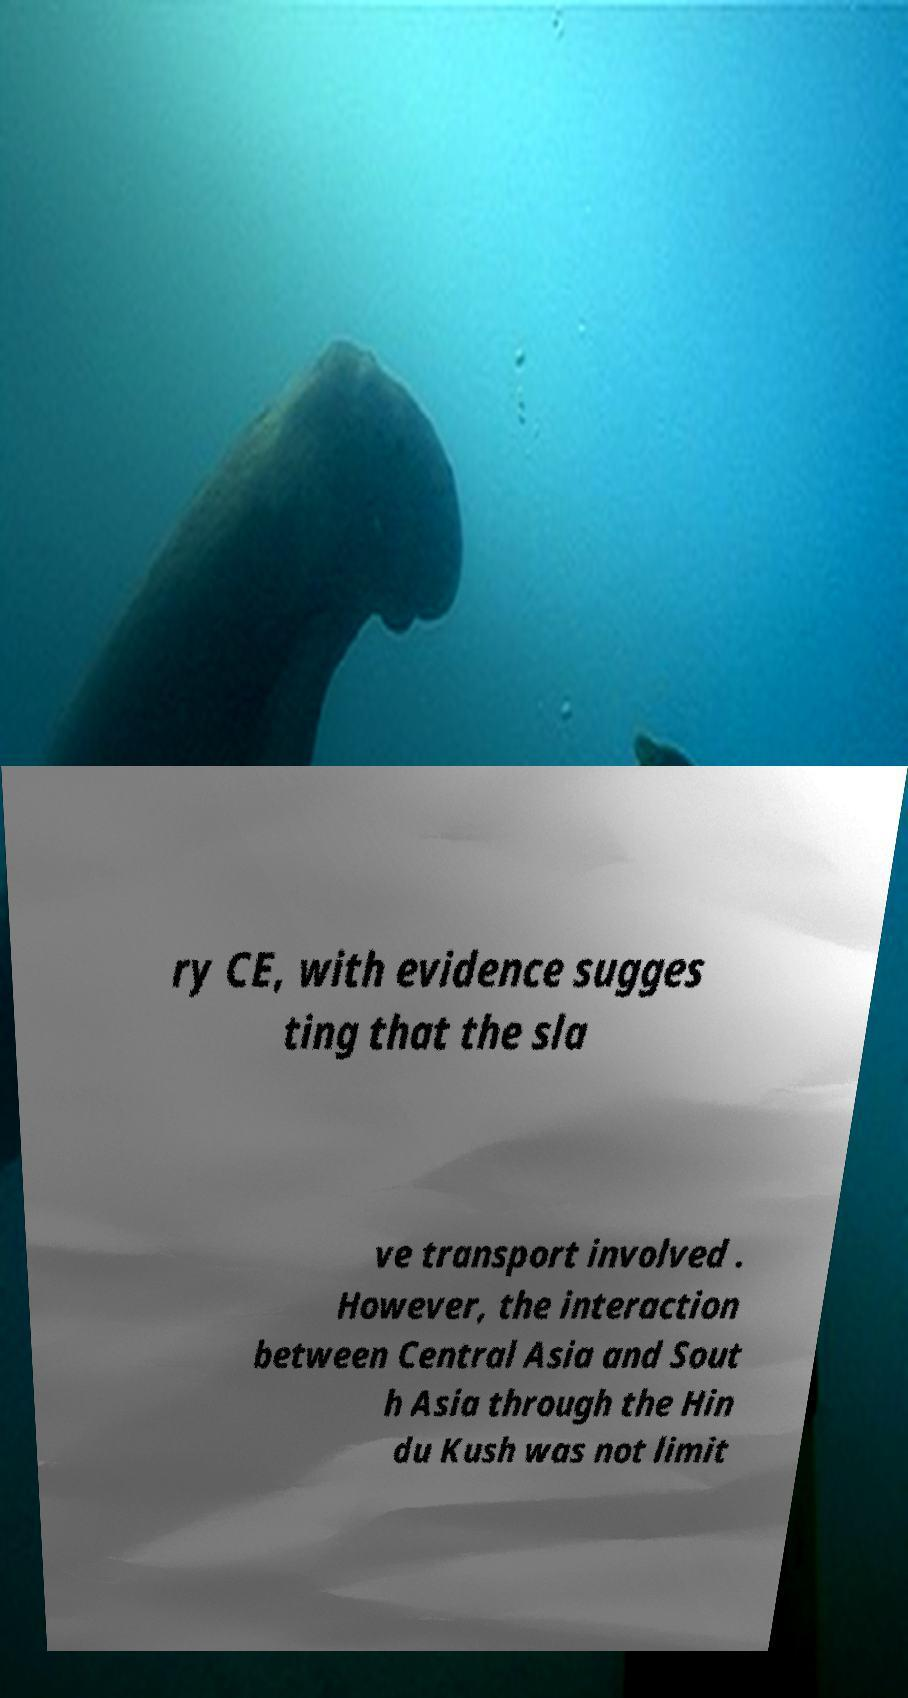Could you extract and type out the text from this image? ry CE, with evidence sugges ting that the sla ve transport involved . However, the interaction between Central Asia and Sout h Asia through the Hin du Kush was not limit 